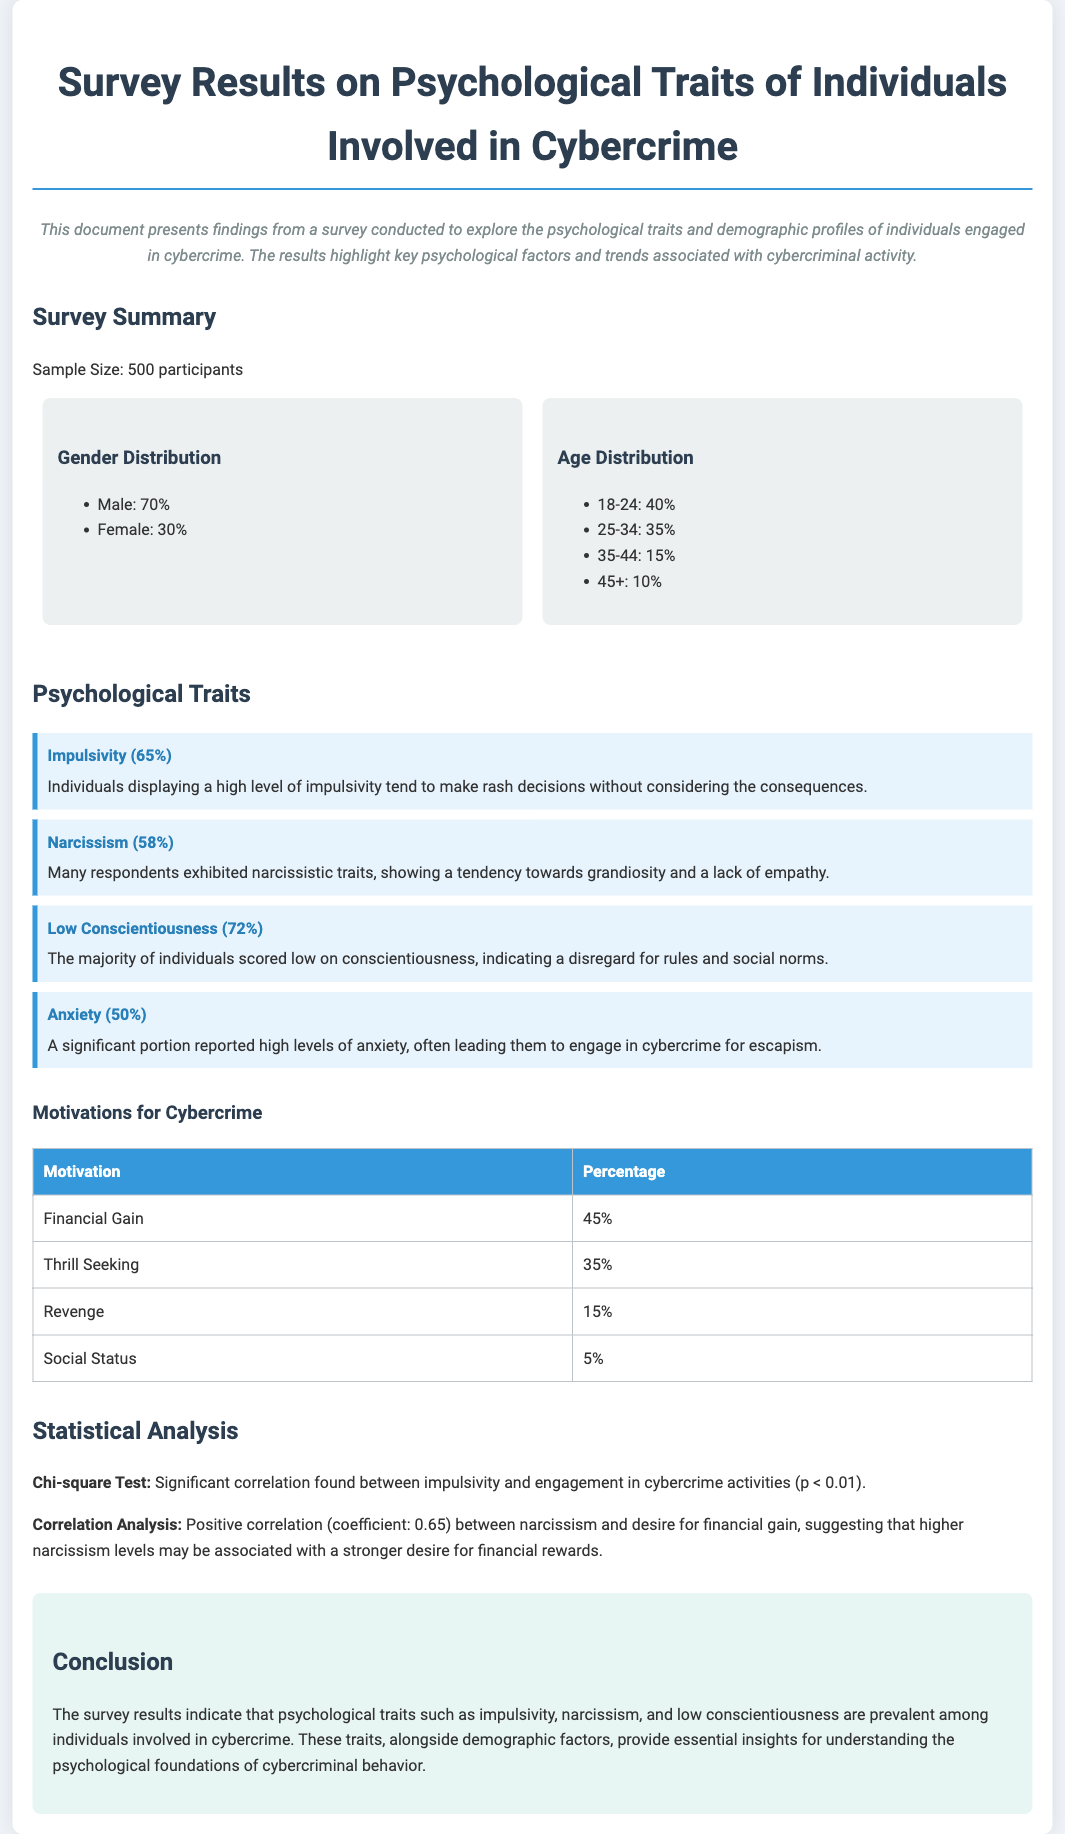What is the sample size of the survey? The sample size is mentioned in the survey summary section as 500 participants.
Answer: 500 participants What percentage of participants identified as male? The gender distribution section indicates that 70% of participants are male.
Answer: 70% What psychological trait had the lowest reported percentage among the respondents? The motivations for cybercrime table shows that 'Social Status' has the lowest percentage at 5%.
Answer: 5% What is the correlation coefficient between narcissism and financial gain? The statistical analysis provides a positive correlation coefficient of 0.65 between narcissism and financial gain.
Answer: 0.65 What is the predominant age group of participants involved in cybercrime? The age distribution section states that 40% of participants are in the 18-24 age group, making it the predominant group.
Answer: 18-24 What psychological trait was found in 72% of respondents? The document indicates that 72% of individuals scored low on conscientiousness.
Answer: Low Conscientiousness Which motivation accounts for the highest percentage in the cybercrime motivations table? The document lists 'Financial Gain' with 45%, as the highest motivation for cybercriminal behavior.
Answer: Financial Gain What significant correlation was found in the chi-square test? The statistical analysis notes a significant correlation between impulsivity and cybercrime engagement (p < 0.01).
Answer: Impulsivity 